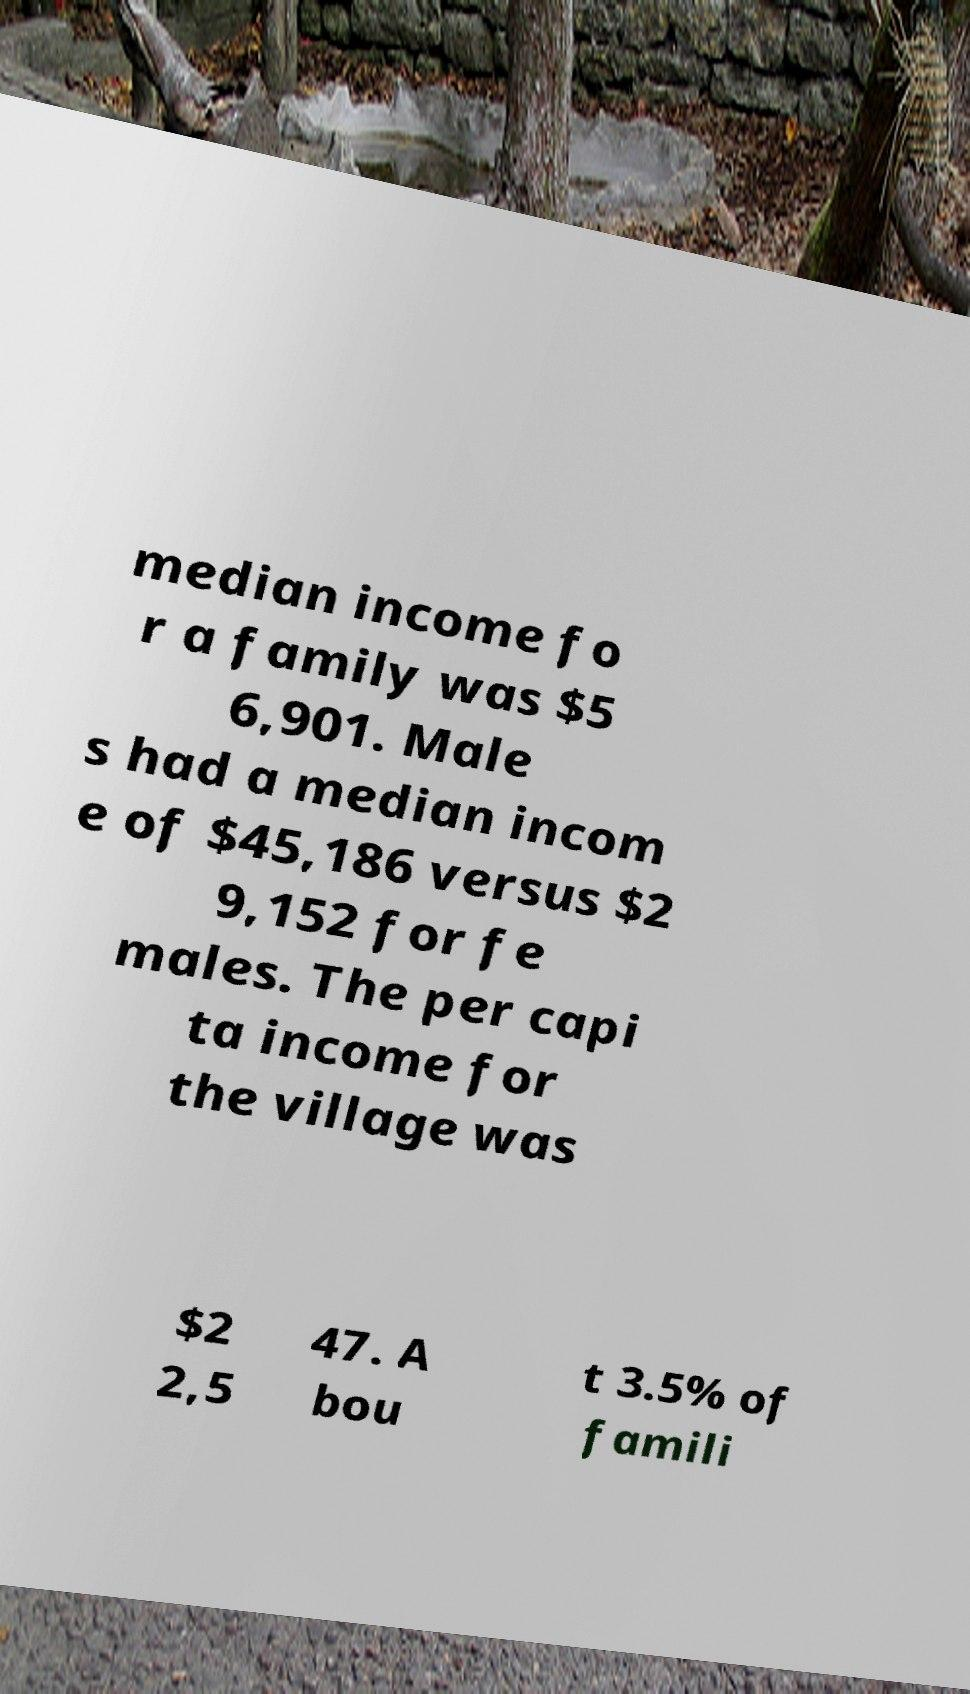Please identify and transcribe the text found in this image. median income fo r a family was $5 6,901. Male s had a median incom e of $45,186 versus $2 9,152 for fe males. The per capi ta income for the village was $2 2,5 47. A bou t 3.5% of famili 